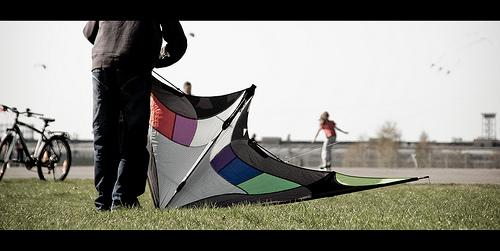Question: how big is the kite?
Choices:
A. It is large.
B. Two feet long.
C. It is small.
D. 12 inches.
Answer with the letter. Answer: A Question: who is using the kite?
Choices:
A. The child.
B. The man standing next to it.
C. The woman.
D. The policeman.
Answer with the letter. Answer: B Question: how is the weather?
Choices:
A. It is cloudy.
B. Lovely.
C. Sweltering.
D. Frigid.
Answer with the letter. Answer: A Question: what is the woman in the red shirt doing?
Choices:
A. Skateboarding.
B. Walking.
C. Sitting down.
D. Waving.
Answer with the letter. Answer: A Question: what is the man in the foreground doing?
Choices:
A. Taking a break.
B. Playing catch.
C. Eating.
D. Inspecting a kite.
Answer with the letter. Answer: D Question: when was this taken?
Choices:
A. Last year.
B. During the day.
C. At night.
D. At Christmas.
Answer with the letter. Answer: B Question: why is the man inspecting the kite?
Choices:
A. He is a judge for the contest.
B. He wants to buy it.
C. He is going to fly it.
D. He wants to repair it.
Answer with the letter. Answer: C 